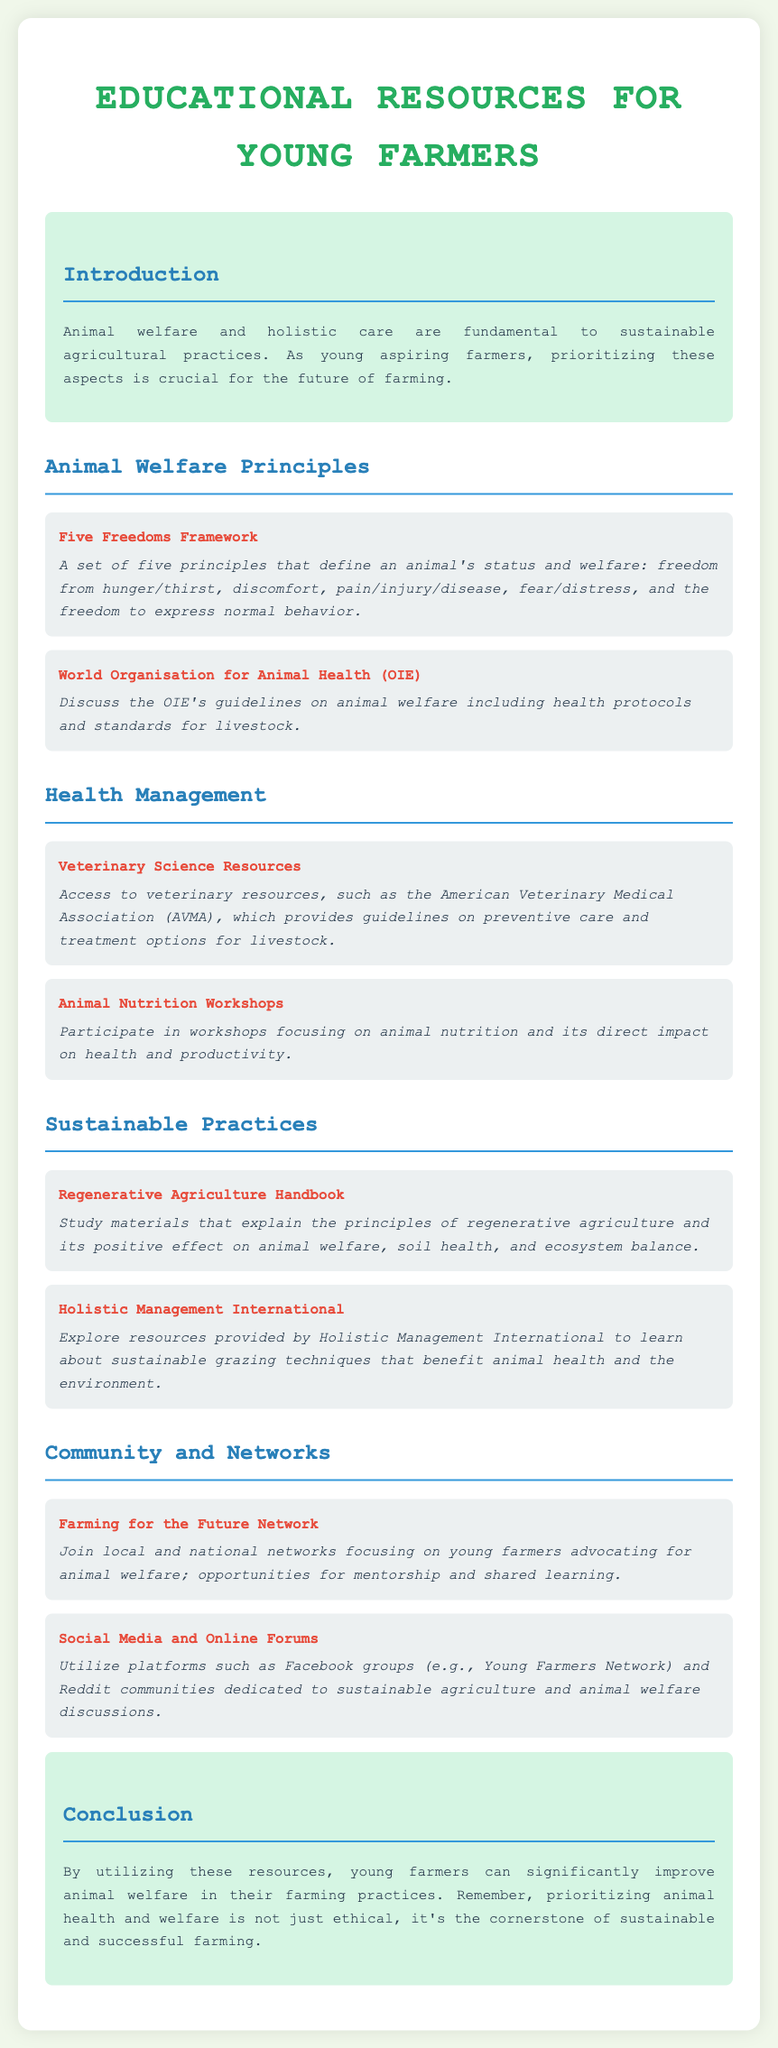What are the Five Freedoms? The document lists the Five Freedoms as principles defining an animal's welfare: freedom from hunger/thirst, discomfort, pain/injury/disease, fear/distress, and the freedom to express normal behavior.
Answer: Freedom from hunger/thirst, discomfort, pain/injury/disease, fear/distress, and the freedom to express normal behavior What organization provides guidelines on animal welfare? The World Organisation for Animal Health (OIE) is mentioned as a provider of guidelines on animal welfare including health protocols.
Answer: World Organisation for Animal Health (OIE) What resources does the American Veterinary Medical Association offer? The document states that the AVMA provides guidelines on preventive care and treatment options for livestock.
Answer: Guidelines on preventive care and treatment options for livestock What is one benefit of regenerative agriculture mentioned? It is noted that regenerative agriculture has a positive effect on animal welfare, soil health, and ecosystem balance.
Answer: Positive effect on animal welfare, soil health, and ecosystem balance What type of workshops are emphasized for young farmers? The document highlights the importance of animal nutrition workshops for understanding its impact on health and productivity.
Answer: Animal nutrition workshops What kind of network is Farming for the Future? It is described as a network focusing on young farmers advocating for animal welfare with opportunities for mentorship and shared learning.
Answer: A network focusing on young farmers advocating for animal welfare What is the conclusion regarding prioritizing animal health and welfare? The conclusion states that prioritizing animal health and welfare is not just ethical but also the cornerstone of sustainable and successful farming.
Answer: Cornerstone of sustainable and successful farming 